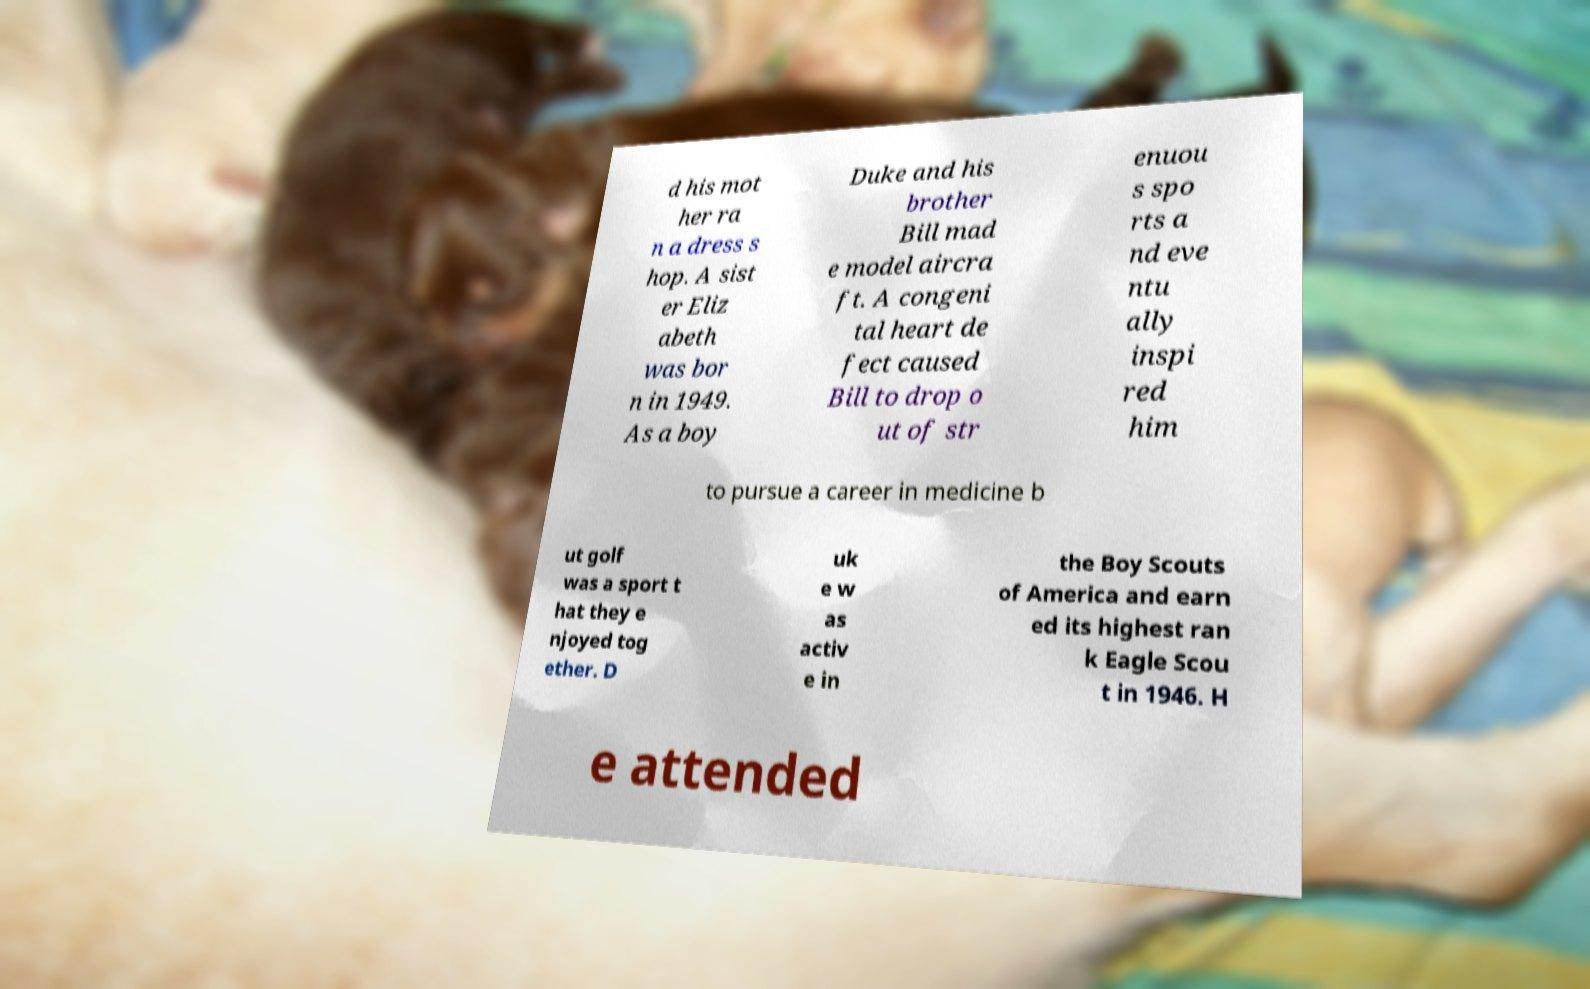Could you assist in decoding the text presented in this image and type it out clearly? d his mot her ra n a dress s hop. A sist er Eliz abeth was bor n in 1949. As a boy Duke and his brother Bill mad e model aircra ft. A congeni tal heart de fect caused Bill to drop o ut of str enuou s spo rts a nd eve ntu ally inspi red him to pursue a career in medicine b ut golf was a sport t hat they e njoyed tog ether. D uk e w as activ e in the Boy Scouts of America and earn ed its highest ran k Eagle Scou t in 1946. H e attended 